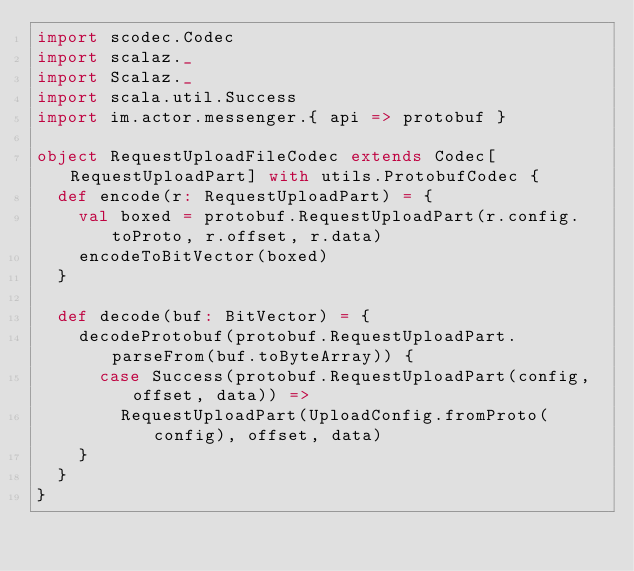Convert code to text. <code><loc_0><loc_0><loc_500><loc_500><_Scala_>import scodec.Codec
import scalaz._
import Scalaz._
import scala.util.Success
import im.actor.messenger.{ api => protobuf }

object RequestUploadFileCodec extends Codec[RequestUploadPart] with utils.ProtobufCodec {
  def encode(r: RequestUploadPart) = {
    val boxed = protobuf.RequestUploadPart(r.config.toProto, r.offset, r.data)
    encodeToBitVector(boxed)
  }

  def decode(buf: BitVector) = {
    decodeProtobuf(protobuf.RequestUploadPart.parseFrom(buf.toByteArray)) {
      case Success(protobuf.RequestUploadPart(config, offset, data)) =>
        RequestUploadPart(UploadConfig.fromProto(config), offset, data)
    }
  }
}
</code> 